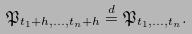Convert formula to latex. <formula><loc_0><loc_0><loc_500><loc_500>\mathfrak { P } _ { t _ { 1 } + h , \dots , t _ { n } + h } \stackrel { d } { = } \mathfrak { P } _ { t _ { 1 } , \dots , t _ { n } } .</formula> 